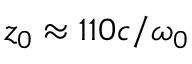<formula> <loc_0><loc_0><loc_500><loc_500>z _ { 0 } \approx 1 1 0 c / \omega _ { 0 }</formula> 